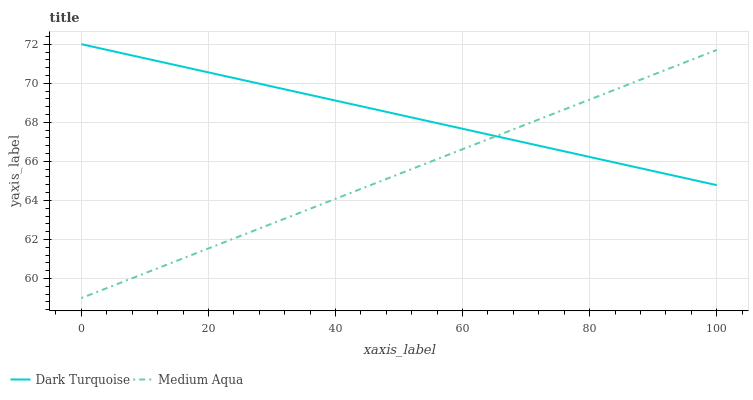Does Medium Aqua have the minimum area under the curve?
Answer yes or no. Yes. Does Dark Turquoise have the maximum area under the curve?
Answer yes or no. Yes. Does Medium Aqua have the maximum area under the curve?
Answer yes or no. No. Is Medium Aqua the smoothest?
Answer yes or no. Yes. Is Dark Turquoise the roughest?
Answer yes or no. Yes. Is Medium Aqua the roughest?
Answer yes or no. No. Does Medium Aqua have the lowest value?
Answer yes or no. Yes. Does Dark Turquoise have the highest value?
Answer yes or no. Yes. Does Medium Aqua have the highest value?
Answer yes or no. No. Does Dark Turquoise intersect Medium Aqua?
Answer yes or no. Yes. Is Dark Turquoise less than Medium Aqua?
Answer yes or no. No. Is Dark Turquoise greater than Medium Aqua?
Answer yes or no. No. 